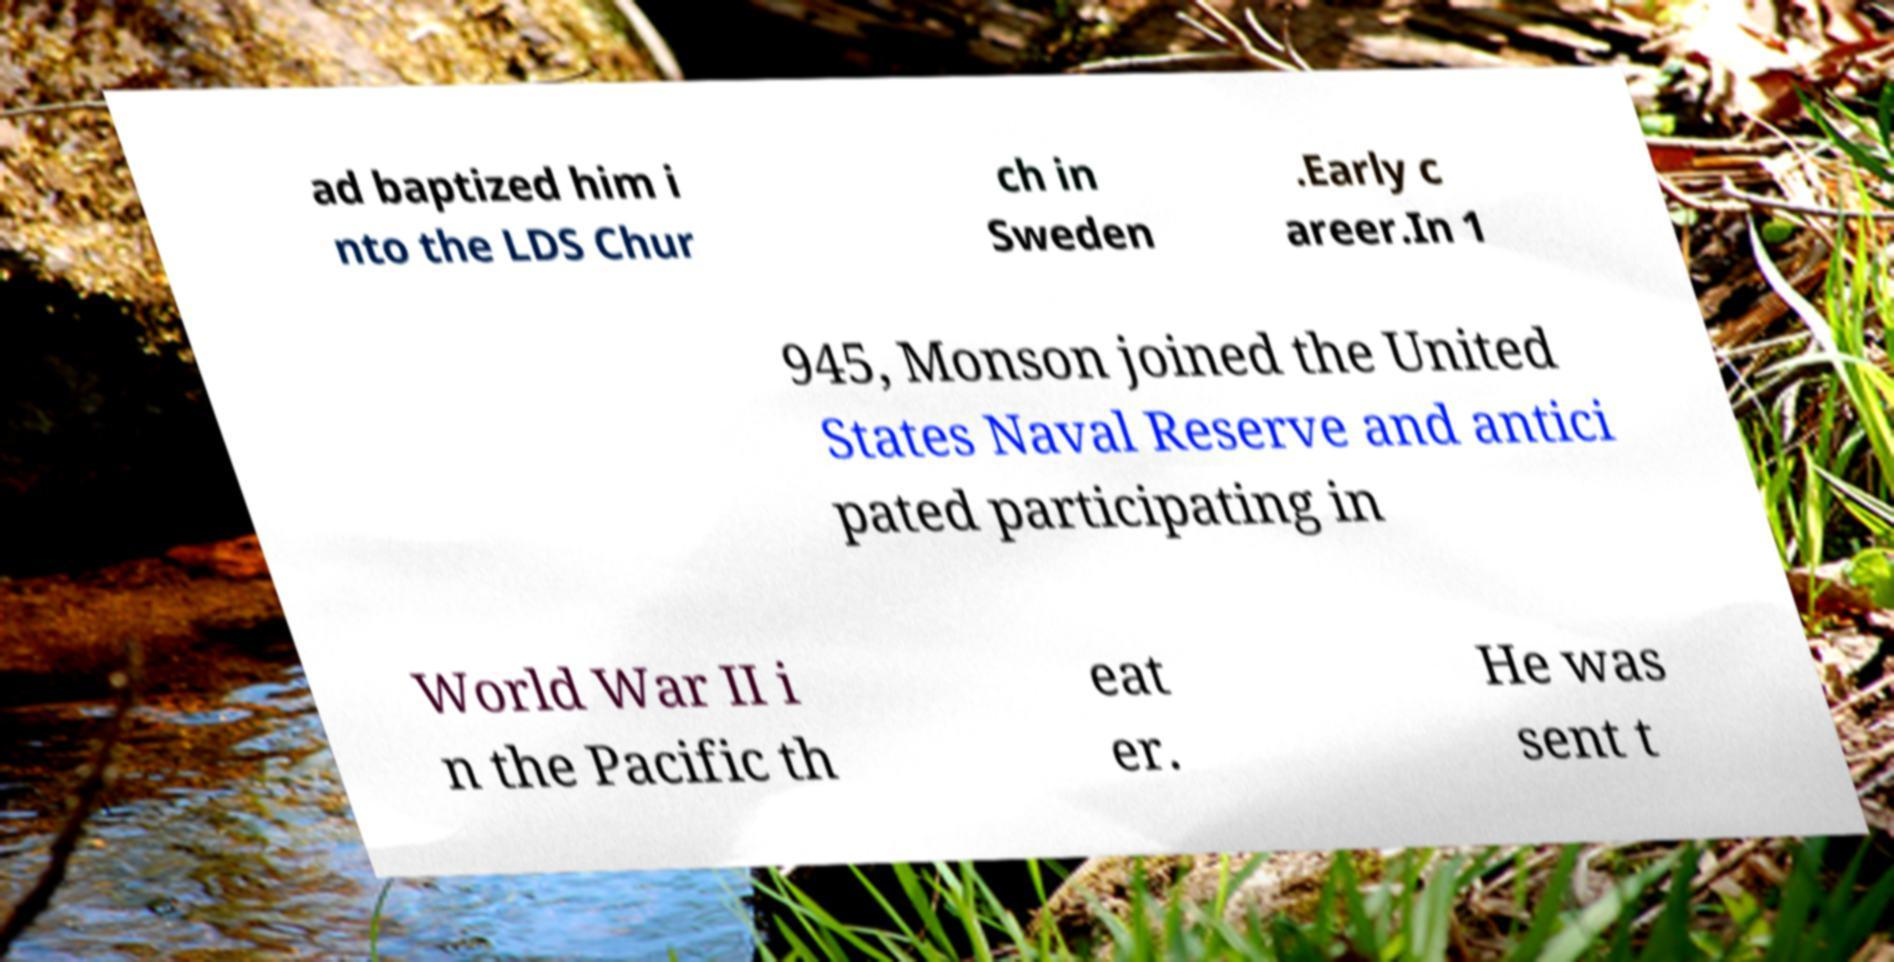There's text embedded in this image that I need extracted. Can you transcribe it verbatim? ad baptized him i nto the LDS Chur ch in Sweden .Early c areer.In 1 945, Monson joined the United States Naval Reserve and antici pated participating in World War II i n the Pacific th eat er. He was sent t 